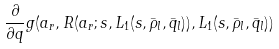<formula> <loc_0><loc_0><loc_500><loc_500>\frac { \partial } { \partial q } g ( a _ { r } , R ( a _ { r } ; s , L _ { 1 } ( s , \bar { \rho } _ { l } , \bar { q } _ { l } ) ) , L _ { 1 } ( s , \bar { \rho } _ { l } , \bar { q } _ { l } ) )</formula> 